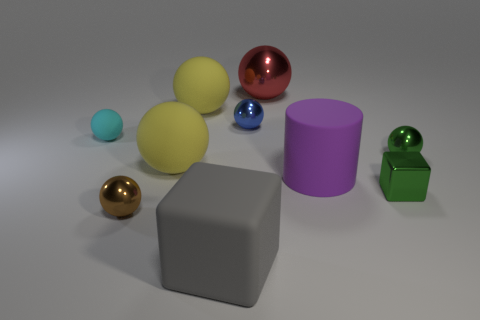How many small things are either green metal blocks or matte objects?
Offer a very short reply. 2. Is there anything else that is the same color as the small shiny block?
Your answer should be compact. Yes. There is a small matte thing; are there any large red things in front of it?
Provide a short and direct response. No. There is a thing that is in front of the tiny metal thing left of the big cube; what is its size?
Keep it short and to the point. Large. Is the number of green blocks in front of the large block the same as the number of green objects in front of the blue shiny sphere?
Make the answer very short. No. Are there any red metallic objects behind the small metal ball right of the large red shiny object?
Keep it short and to the point. Yes. There is a metallic ball that is in front of the green metallic object in front of the purple thing; what number of small blue shiny objects are right of it?
Your answer should be very brief. 1. Is the number of large spheres less than the number of shiny things?
Offer a terse response. Yes. There is a tiny green shiny object behind the small green shiny block; is it the same shape as the large thing in front of the small brown thing?
Offer a very short reply. No. What is the color of the small matte ball?
Offer a very short reply. Cyan. 